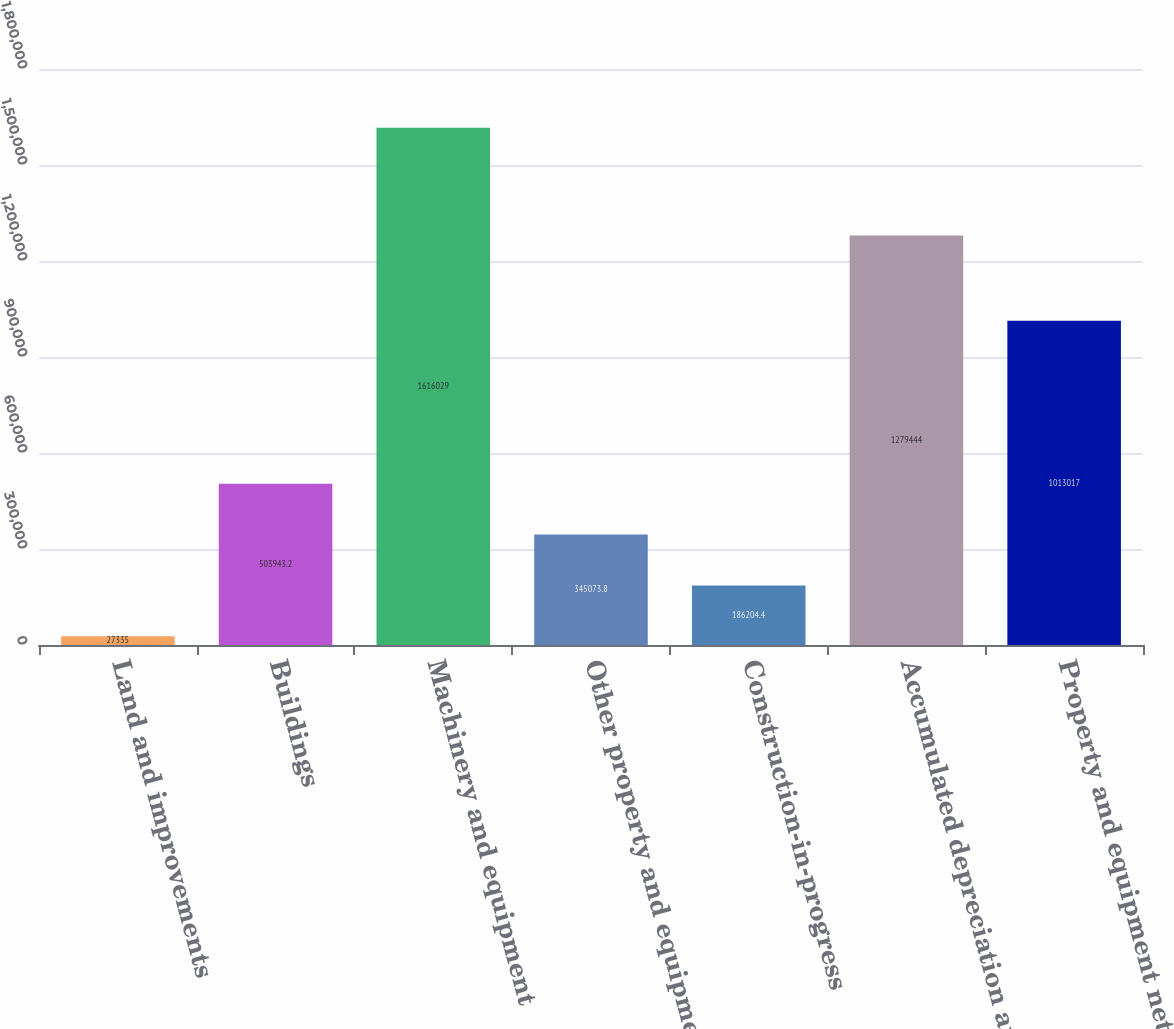Convert chart. <chart><loc_0><loc_0><loc_500><loc_500><bar_chart><fcel>Land and improvements<fcel>Buildings<fcel>Machinery and equipment<fcel>Other property and equipment<fcel>Construction-in-progress<fcel>Accumulated depreciation and<fcel>Property and equipment net<nl><fcel>27335<fcel>503943<fcel>1.61603e+06<fcel>345074<fcel>186204<fcel>1.27944e+06<fcel>1.01302e+06<nl></chart> 